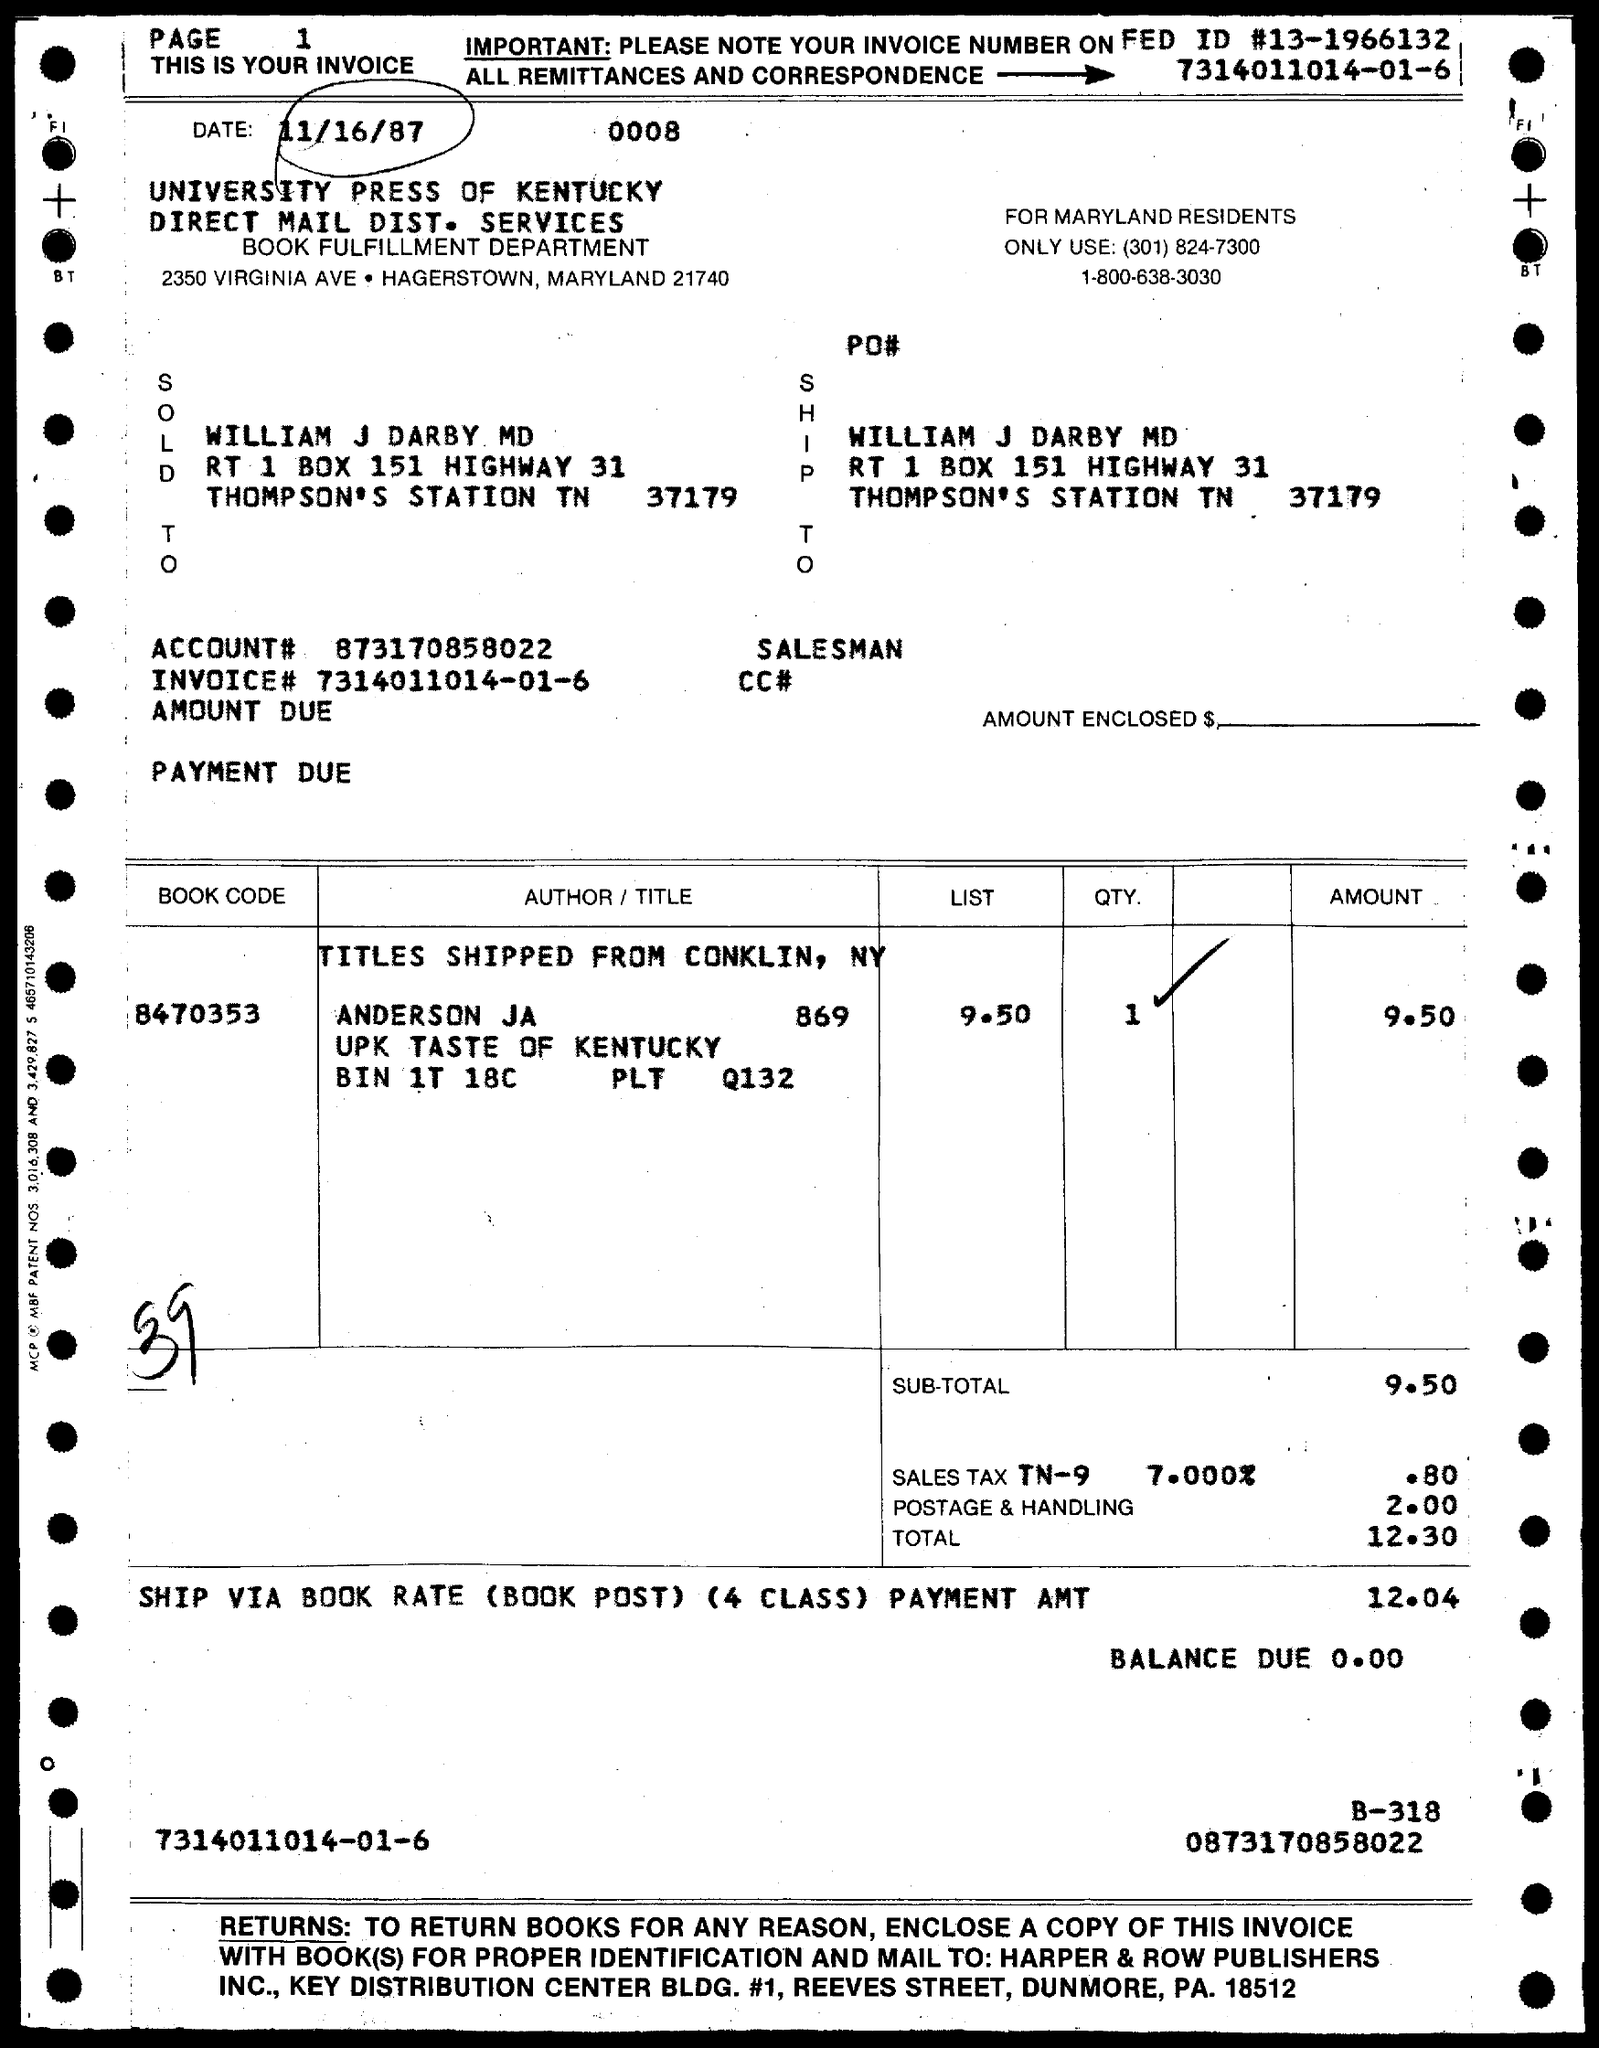Outline some significant characteristics in this image. The book code is 8470353... The date is 11/16/87. 